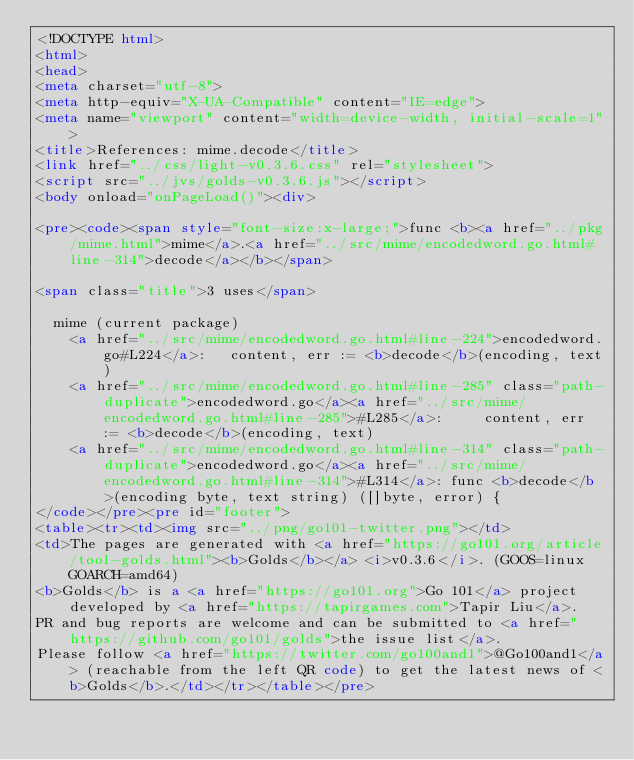<code> <loc_0><loc_0><loc_500><loc_500><_HTML_><!DOCTYPE html>
<html>
<head>
<meta charset="utf-8">
<meta http-equiv="X-UA-Compatible" content="IE=edge">
<meta name="viewport" content="width=device-width, initial-scale=1">
<title>References: mime.decode</title>
<link href="../css/light-v0.3.6.css" rel="stylesheet">
<script src="../jvs/golds-v0.3.6.js"></script>
<body onload="onPageLoad()"><div>

<pre><code><span style="font-size:x-large;">func <b><a href="../pkg/mime.html">mime</a>.<a href="../src/mime/encodedword.go.html#line-314">decode</a></b></span>

<span class="title">3 uses</span>

	mime (current package)
		<a href="../src/mime/encodedword.go.html#line-224">encodedword.go#L224</a>: 	content, err := <b>decode</b>(encoding, text)
		<a href="../src/mime/encodedword.go.html#line-285" class="path-duplicate">encodedword.go</a><a href="../src/mime/encodedword.go.html#line-285">#L285</a>: 		content, err := <b>decode</b>(encoding, text)
		<a href="../src/mime/encodedword.go.html#line-314" class="path-duplicate">encodedword.go</a><a href="../src/mime/encodedword.go.html#line-314">#L314</a>: func <b>decode</b>(encoding byte, text string) ([]byte, error) {
</code></pre><pre id="footer">
<table><tr><td><img src="../png/go101-twitter.png"></td>
<td>The pages are generated with <a href="https://go101.org/article/tool-golds.html"><b>Golds</b></a> <i>v0.3.6</i>. (GOOS=linux GOARCH=amd64)
<b>Golds</b> is a <a href="https://go101.org">Go 101</a> project developed by <a href="https://tapirgames.com">Tapir Liu</a>.
PR and bug reports are welcome and can be submitted to <a href="https://github.com/go101/golds">the issue list</a>.
Please follow <a href="https://twitter.com/go100and1">@Go100and1</a> (reachable from the left QR code) to get the latest news of <b>Golds</b>.</td></tr></table></pre></code> 